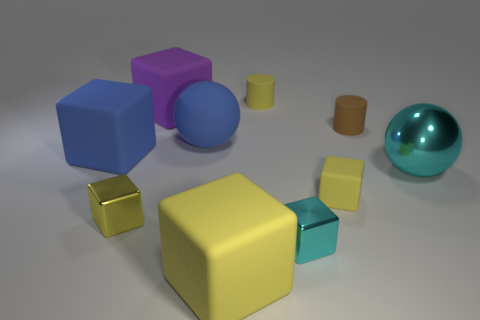There is a ball that is in front of the big blue matte cube that is to the left of the tiny yellow cube that is left of the large yellow thing; what is its color?
Offer a terse response. Cyan. Are there more cylinders than small cyan matte balls?
Ensure brevity in your answer.  Yes. What number of rubber things are to the left of the big blue ball and behind the brown cylinder?
Provide a short and direct response. 1. There is a big thing that is in front of the small yellow metallic object; what number of yellow rubber cubes are on the left side of it?
Your answer should be compact. 0. There is a brown thing that is behind the cyan metallic cube; is it the same size as the cyan object on the left side of the tiny brown thing?
Your answer should be very brief. Yes. How many gray metal blocks are there?
Keep it short and to the point. 0. What number of tiny things have the same material as the brown cylinder?
Give a very brief answer. 2. Are there an equal number of yellow cylinders that are on the right side of the cyan metallic cube and small brown cylinders?
Provide a short and direct response. No. There is a tiny block that is the same color as the shiny ball; what material is it?
Offer a terse response. Metal. There is a brown matte object; does it have the same size as the yellow rubber object behind the large cyan metal thing?
Offer a terse response. Yes. 